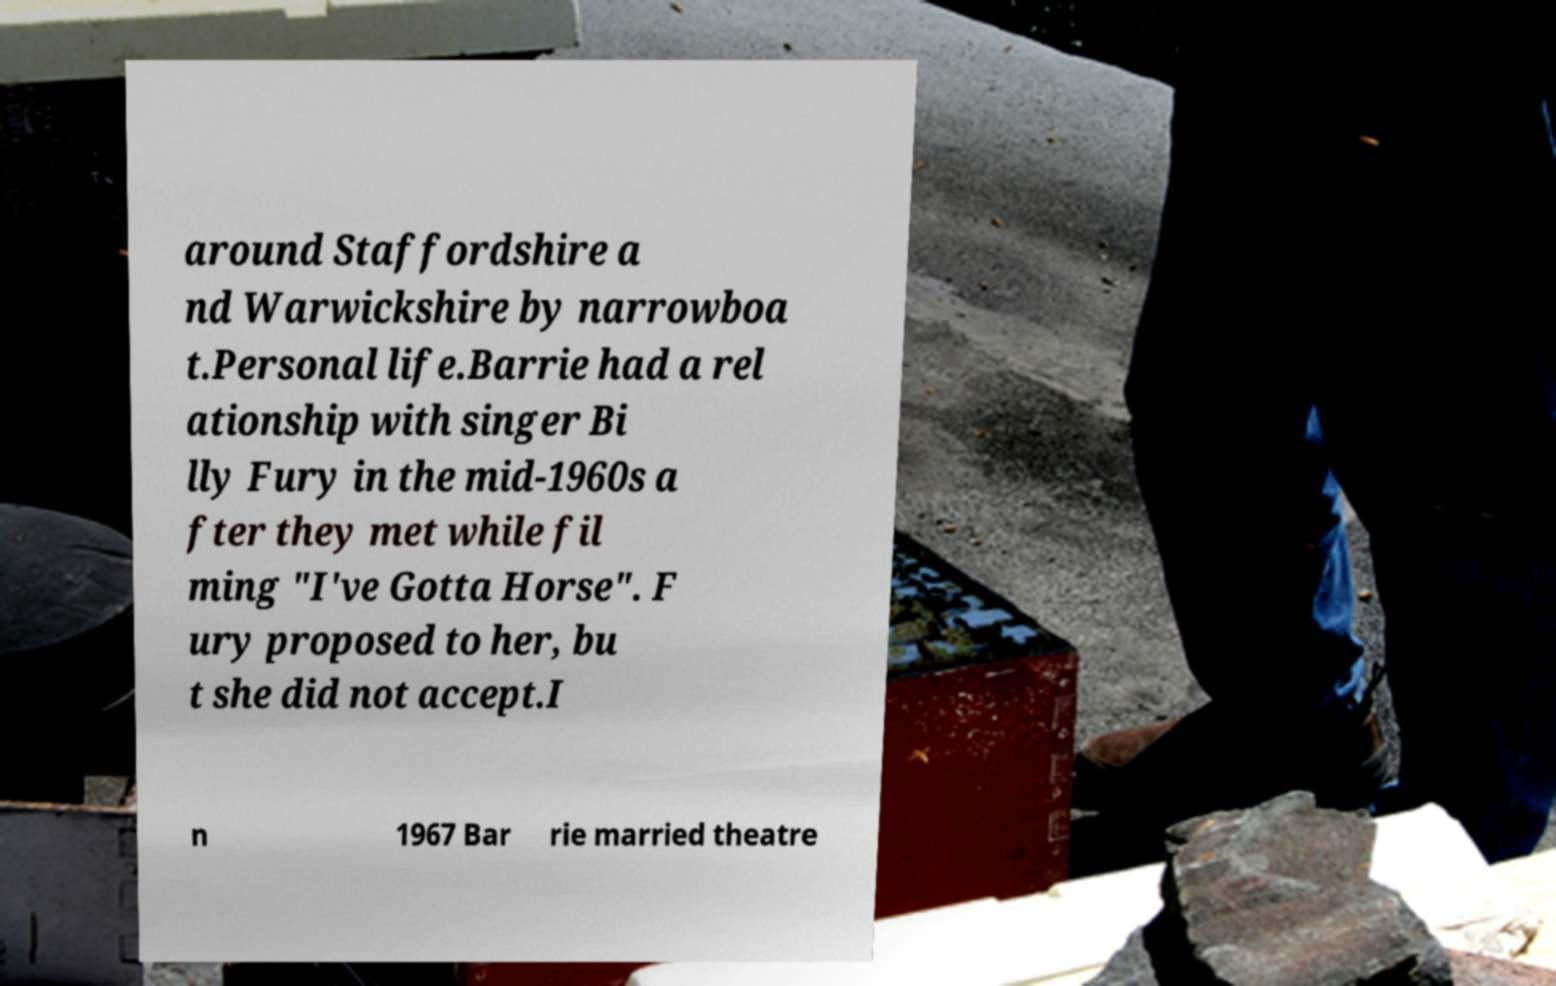Please read and relay the text visible in this image. What does it say? around Staffordshire a nd Warwickshire by narrowboa t.Personal life.Barrie had a rel ationship with singer Bi lly Fury in the mid-1960s a fter they met while fil ming "I've Gotta Horse". F ury proposed to her, bu t she did not accept.I n 1967 Bar rie married theatre 